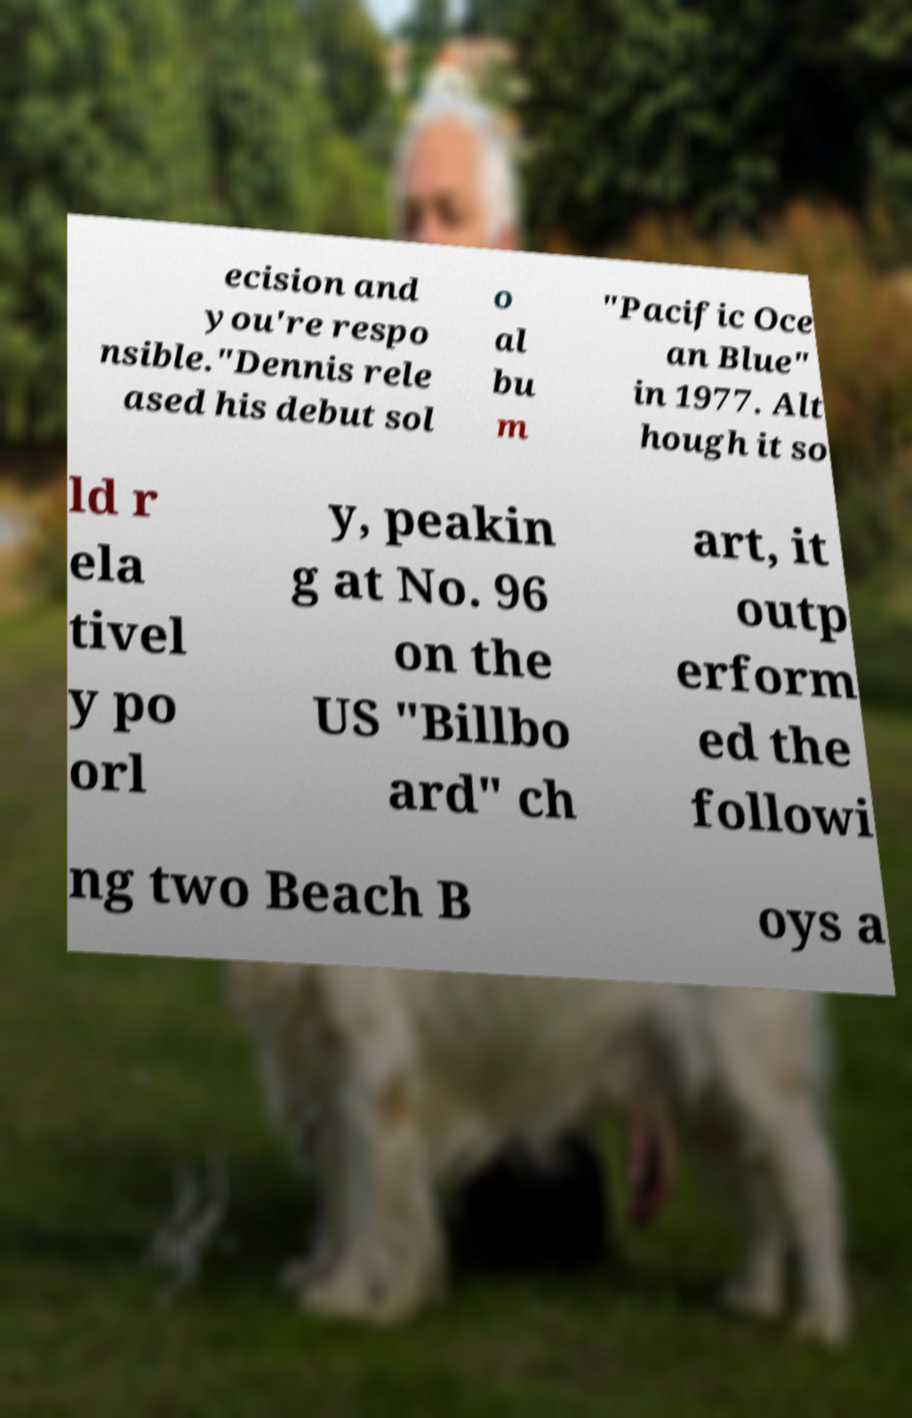There's text embedded in this image that I need extracted. Can you transcribe it verbatim? ecision and you're respo nsible."Dennis rele ased his debut sol o al bu m "Pacific Oce an Blue" in 1977. Alt hough it so ld r ela tivel y po orl y, peakin g at No. 96 on the US "Billbo ard" ch art, it outp erform ed the followi ng two Beach B oys a 